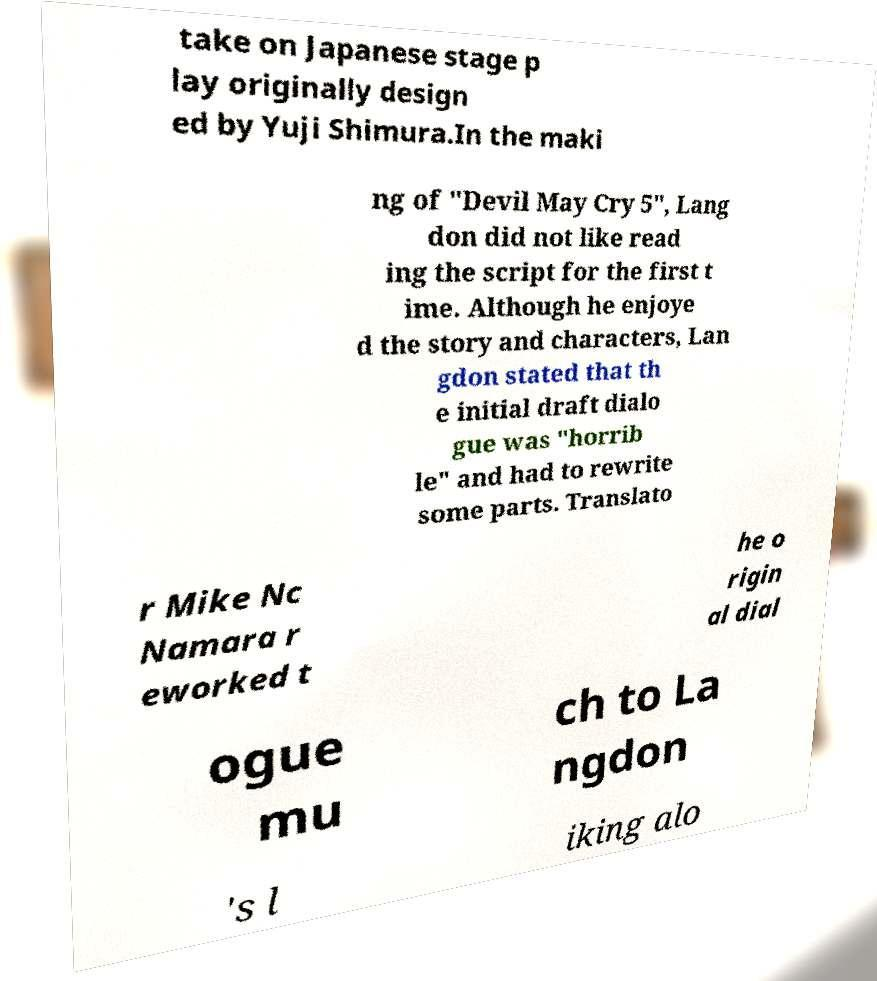Please identify and transcribe the text found in this image. take on Japanese stage p lay originally design ed by Yuji Shimura.In the maki ng of "Devil May Cry 5", Lang don did not like read ing the script for the first t ime. Although he enjoye d the story and characters, Lan gdon stated that th e initial draft dialo gue was "horrib le" and had to rewrite some parts. Translato r Mike Nc Namara r eworked t he o rigin al dial ogue mu ch to La ngdon 's l iking alo 